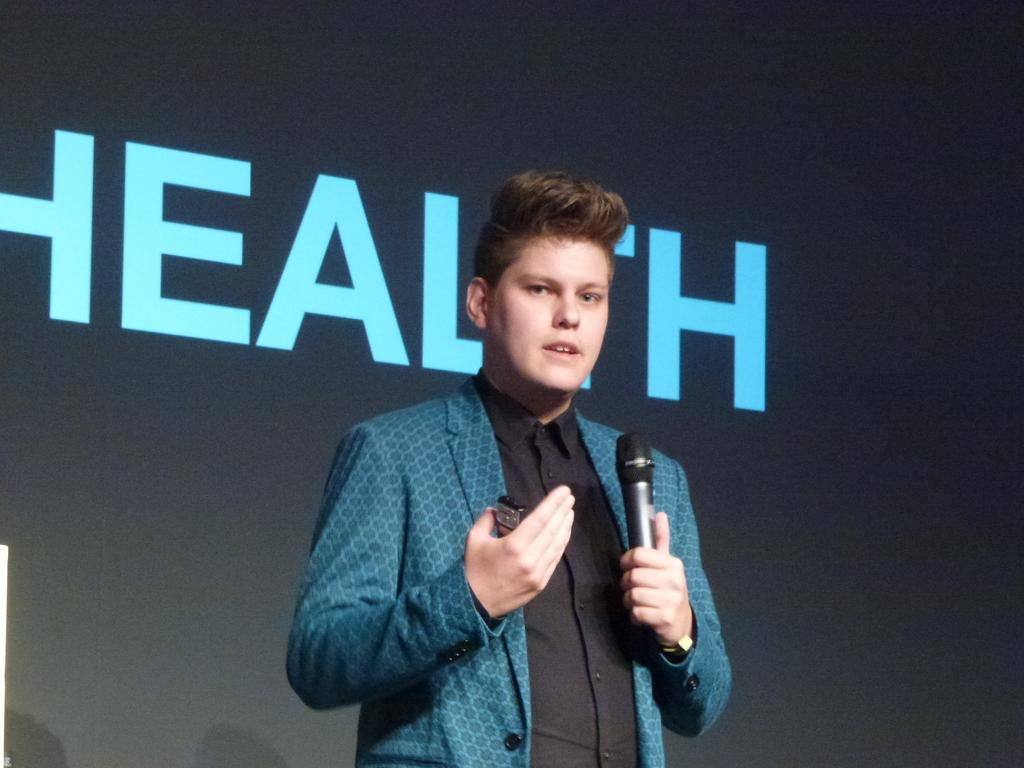What is the main subject of the image? There is a person standing in the center of the image. What is the person holding in the image? The person is holding a mic. What can be seen in the background of the image? There is a screen in the background of the image. What type of butter is being used to grease the sofa in the image? There is no sofa or butter present in the image. 